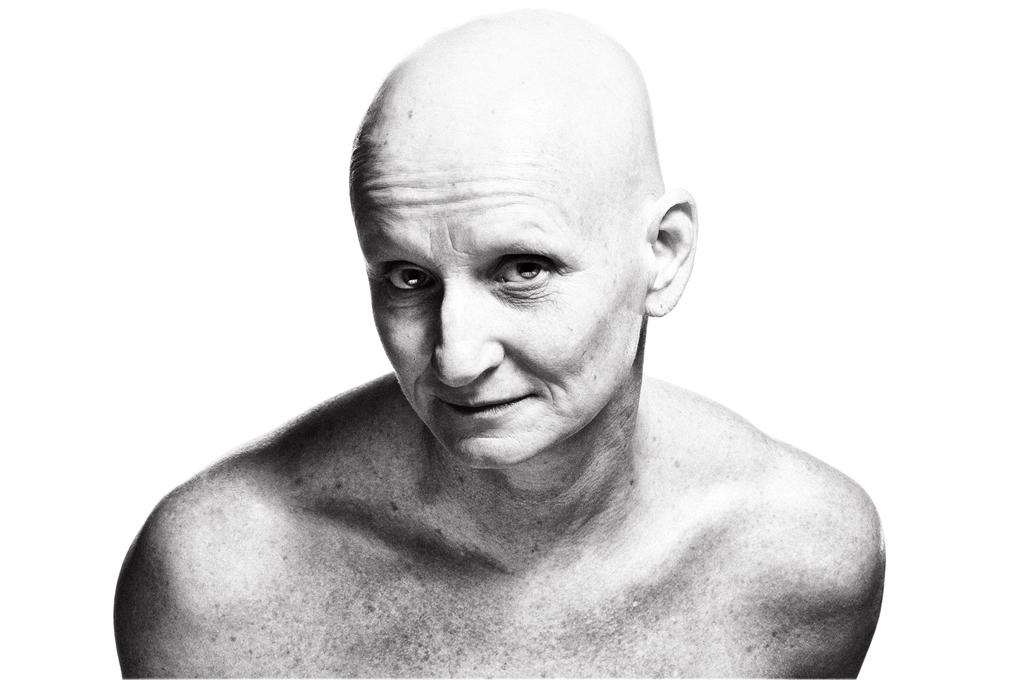Who is the main subject in the picture? There is an old man in the picture. What can be observed about the old man's hair? The old man has bald hair. What is the old man's facial expression in the picture? The old man is smiling. What is the old man doing in the picture? The old man is posing for the camera. What is the color of the background in the picture? There is a white background in the picture. What type of beast can be seen lurking in the background of the picture? There is no beast present in the picture; the background is white. 